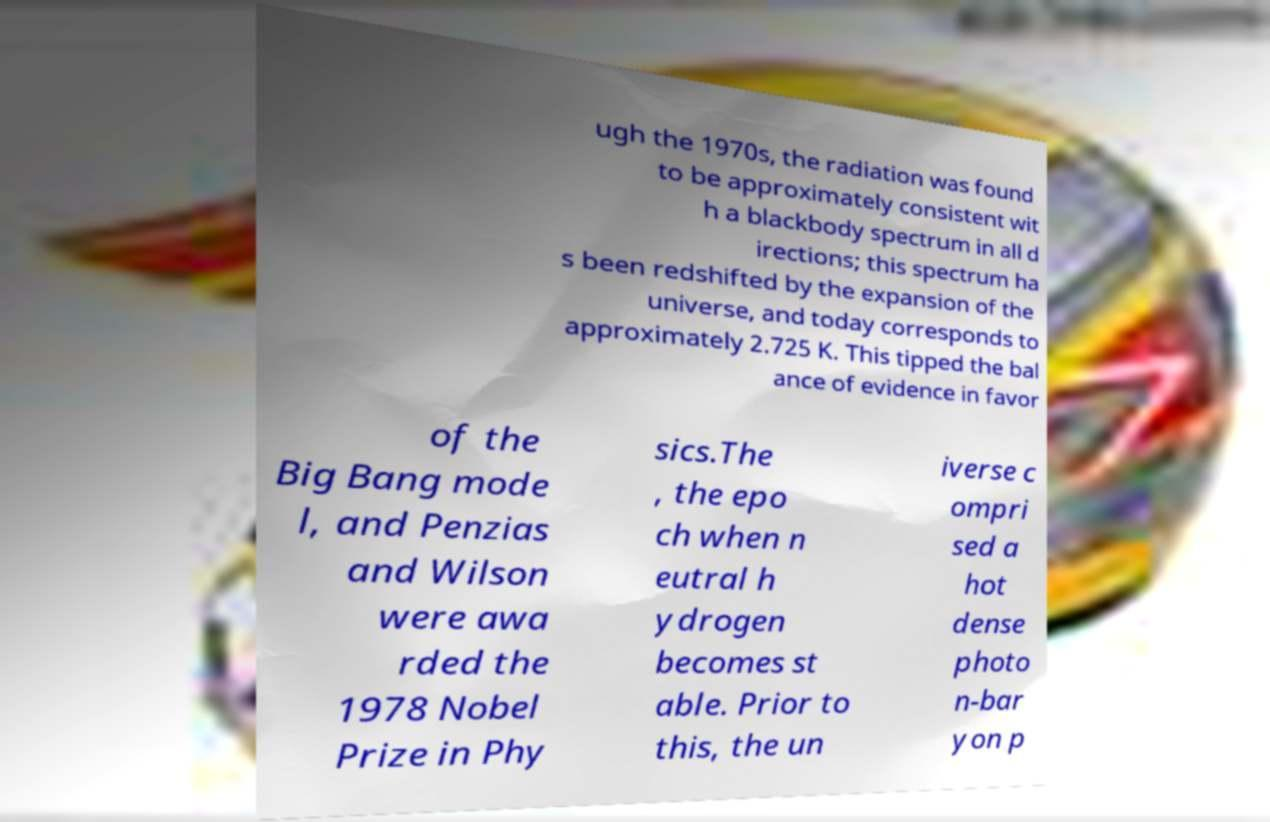Can you accurately transcribe the text from the provided image for me? ugh the 1970s, the radiation was found to be approximately consistent wit h a blackbody spectrum in all d irections; this spectrum ha s been redshifted by the expansion of the universe, and today corresponds to approximately 2.725 K. This tipped the bal ance of evidence in favor of the Big Bang mode l, and Penzias and Wilson were awa rded the 1978 Nobel Prize in Phy sics.The , the epo ch when n eutral h ydrogen becomes st able. Prior to this, the un iverse c ompri sed a hot dense photo n-bar yon p 